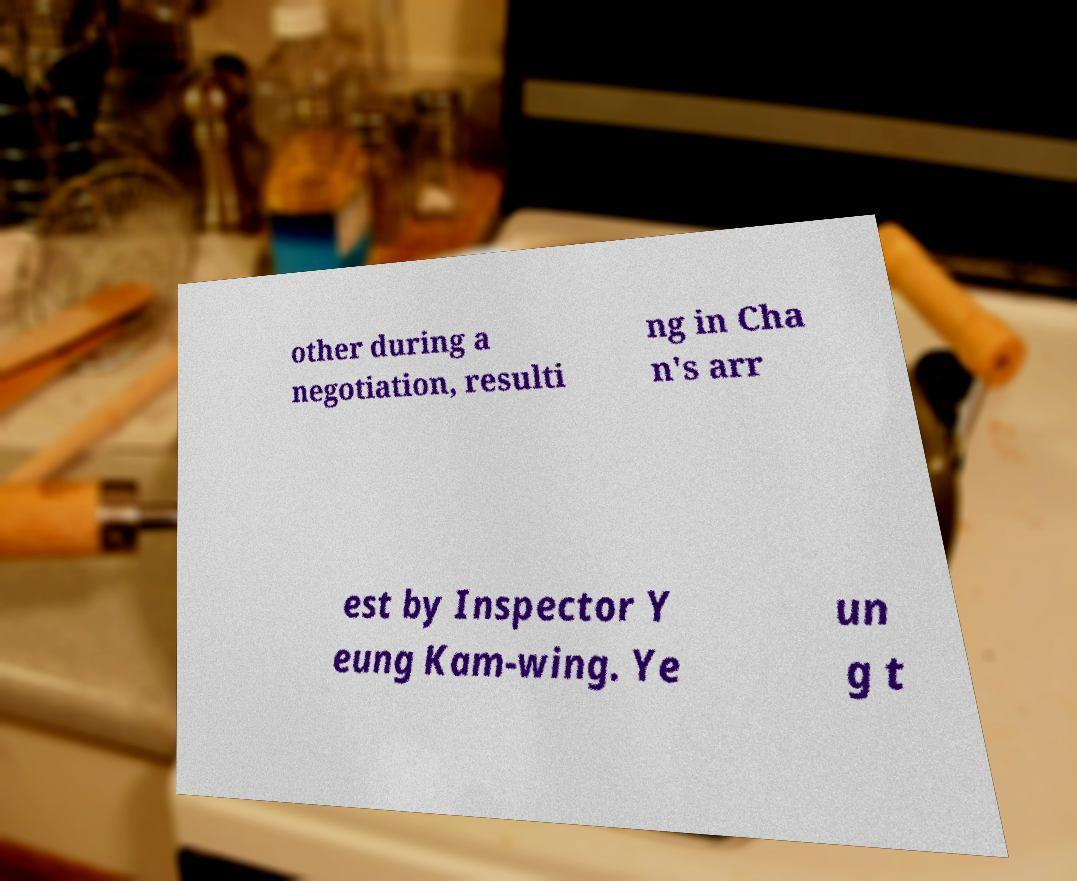Can you read and provide the text displayed in the image?This photo seems to have some interesting text. Can you extract and type it out for me? other during a negotiation, resulti ng in Cha n's arr est by Inspector Y eung Kam-wing. Ye un g t 